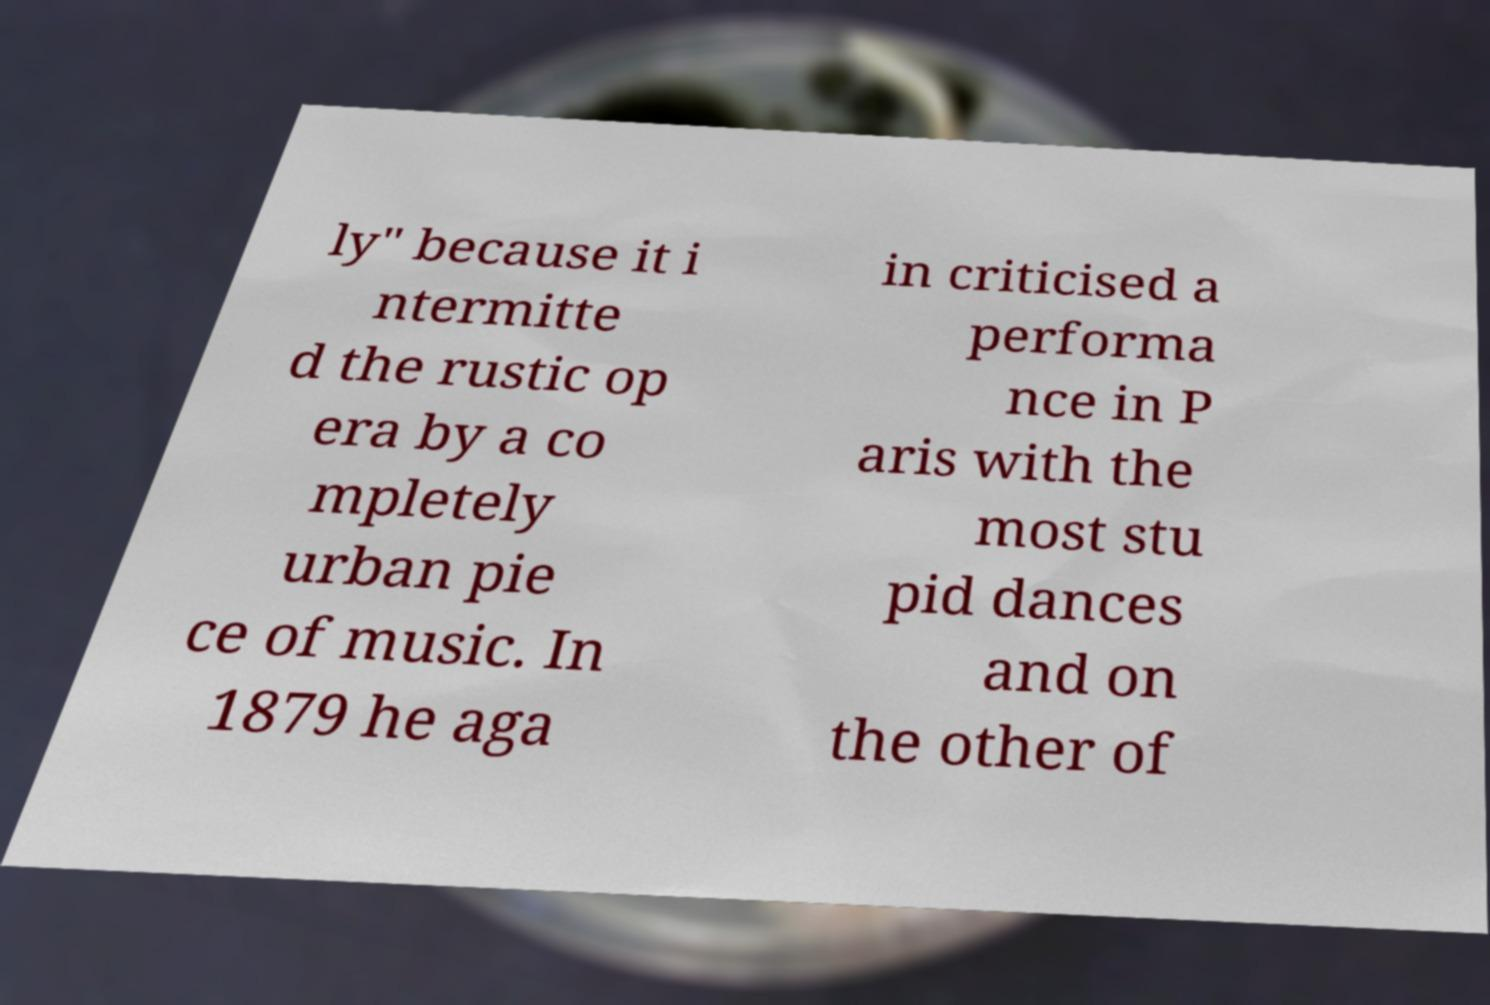For documentation purposes, I need the text within this image transcribed. Could you provide that? ly" because it i ntermitte d the rustic op era by a co mpletely urban pie ce of music. In 1879 he aga in criticised a performa nce in P aris with the most stu pid dances and on the other of 